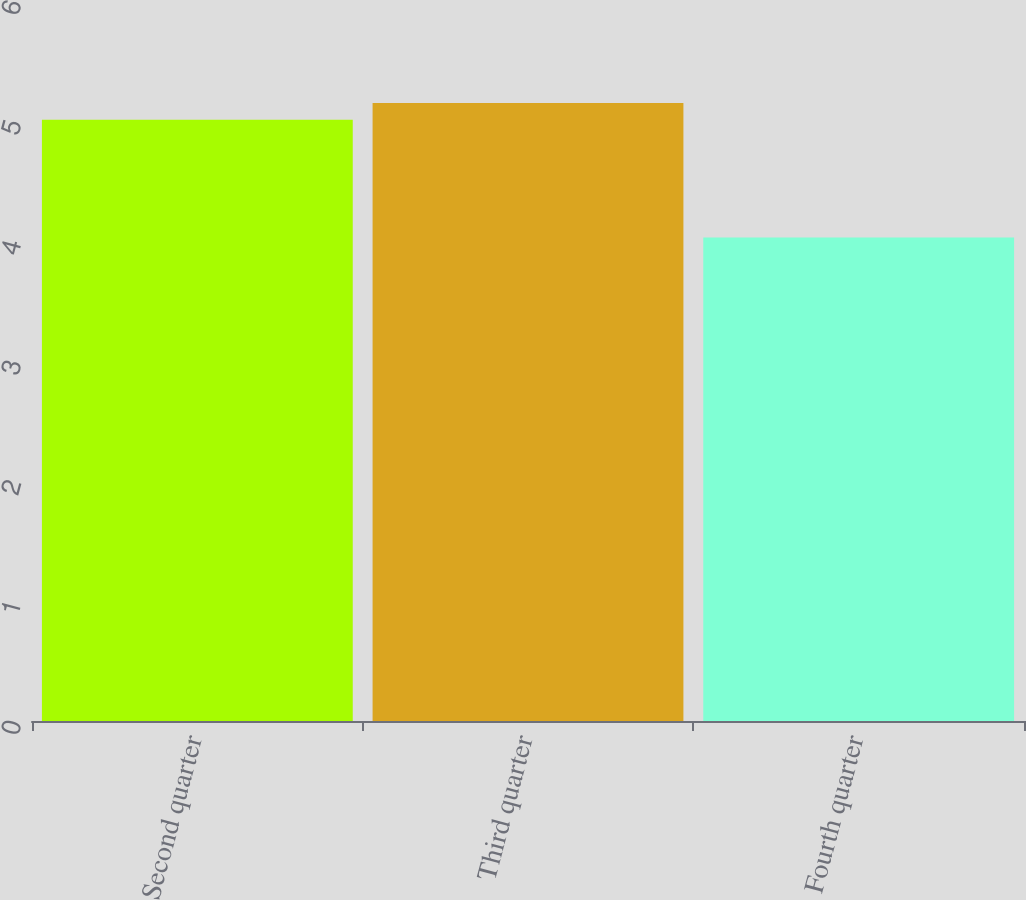Convert chart. <chart><loc_0><loc_0><loc_500><loc_500><bar_chart><fcel>Second quarter<fcel>Third quarter<fcel>Fourth quarter<nl><fcel>5.01<fcel>5.15<fcel>4.03<nl></chart> 